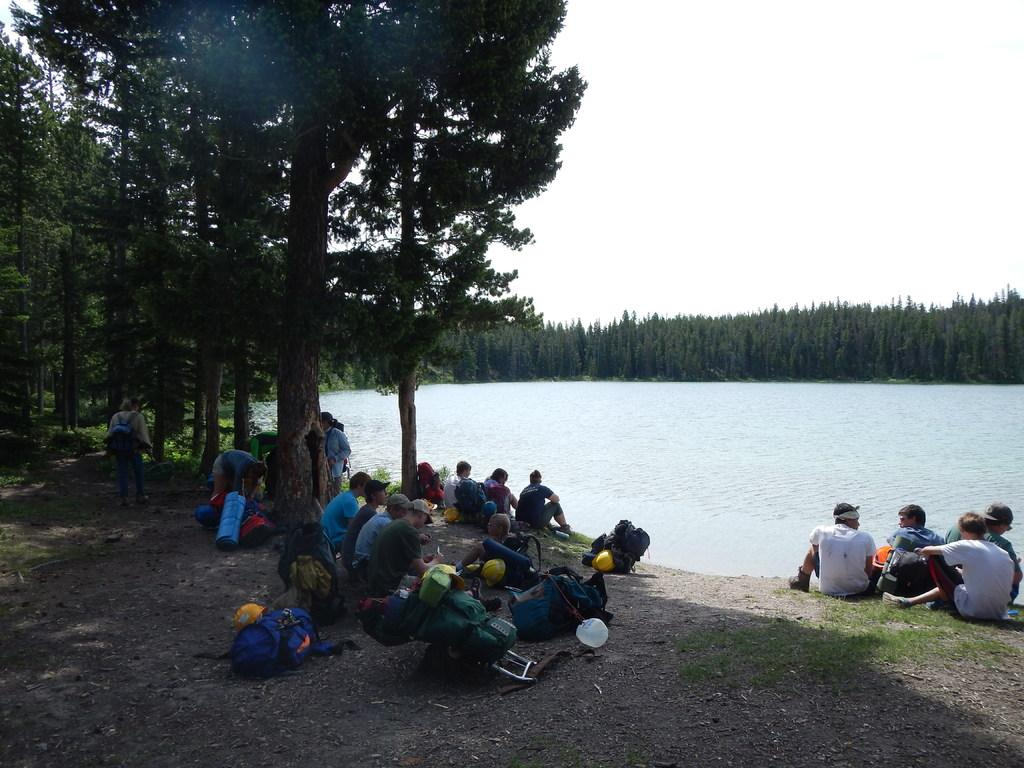What are the people in the image doing? There is a group of people sitting in the image. What items can be seen near the people? There are bags and helmets visible in the image. What is the setting of the image? There is water and trees visible in the image, and the sky is visible in the background. What type of grain is being harvested in the image? There is no grain present in the image; it features a group of people sitting with bags and helmets near water and trees. Can you see any hats or vests on the people in the image? The provided facts do not mention any hats or vests; only helmets are mentioned. 